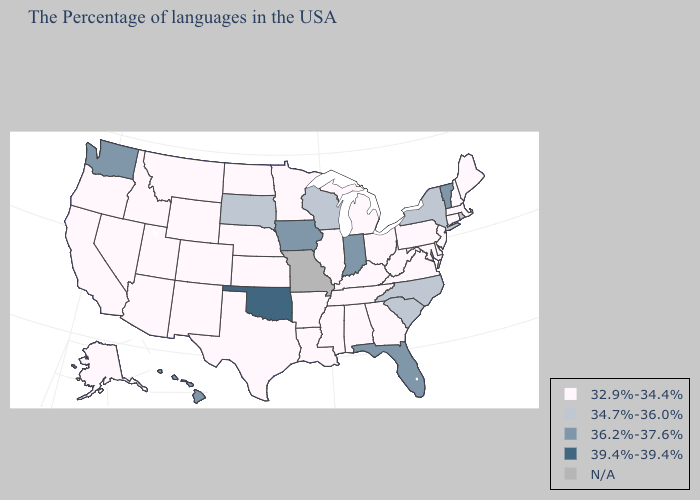What is the value of Vermont?
Concise answer only. 36.2%-37.6%. Among the states that border Nebraska , does Kansas have the highest value?
Give a very brief answer. No. What is the lowest value in the Northeast?
Keep it brief. 32.9%-34.4%. Does Delaware have the highest value in the South?
Be succinct. No. What is the highest value in states that border Tennessee?
Answer briefly. 34.7%-36.0%. What is the value of New Hampshire?
Concise answer only. 32.9%-34.4%. What is the highest value in the Northeast ?
Short answer required. 36.2%-37.6%. Does Kentucky have the lowest value in the South?
Answer briefly. Yes. Which states have the highest value in the USA?
Write a very short answer. Oklahoma. Name the states that have a value in the range 34.7%-36.0%?
Give a very brief answer. Rhode Island, New York, North Carolina, South Carolina, Wisconsin, South Dakota. Name the states that have a value in the range 39.4%-39.4%?
Give a very brief answer. Oklahoma. What is the highest value in the Northeast ?
Give a very brief answer. 36.2%-37.6%. What is the value of California?
Quick response, please. 32.9%-34.4%. 